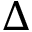<formula> <loc_0><loc_0><loc_500><loc_500>\Delta</formula> 